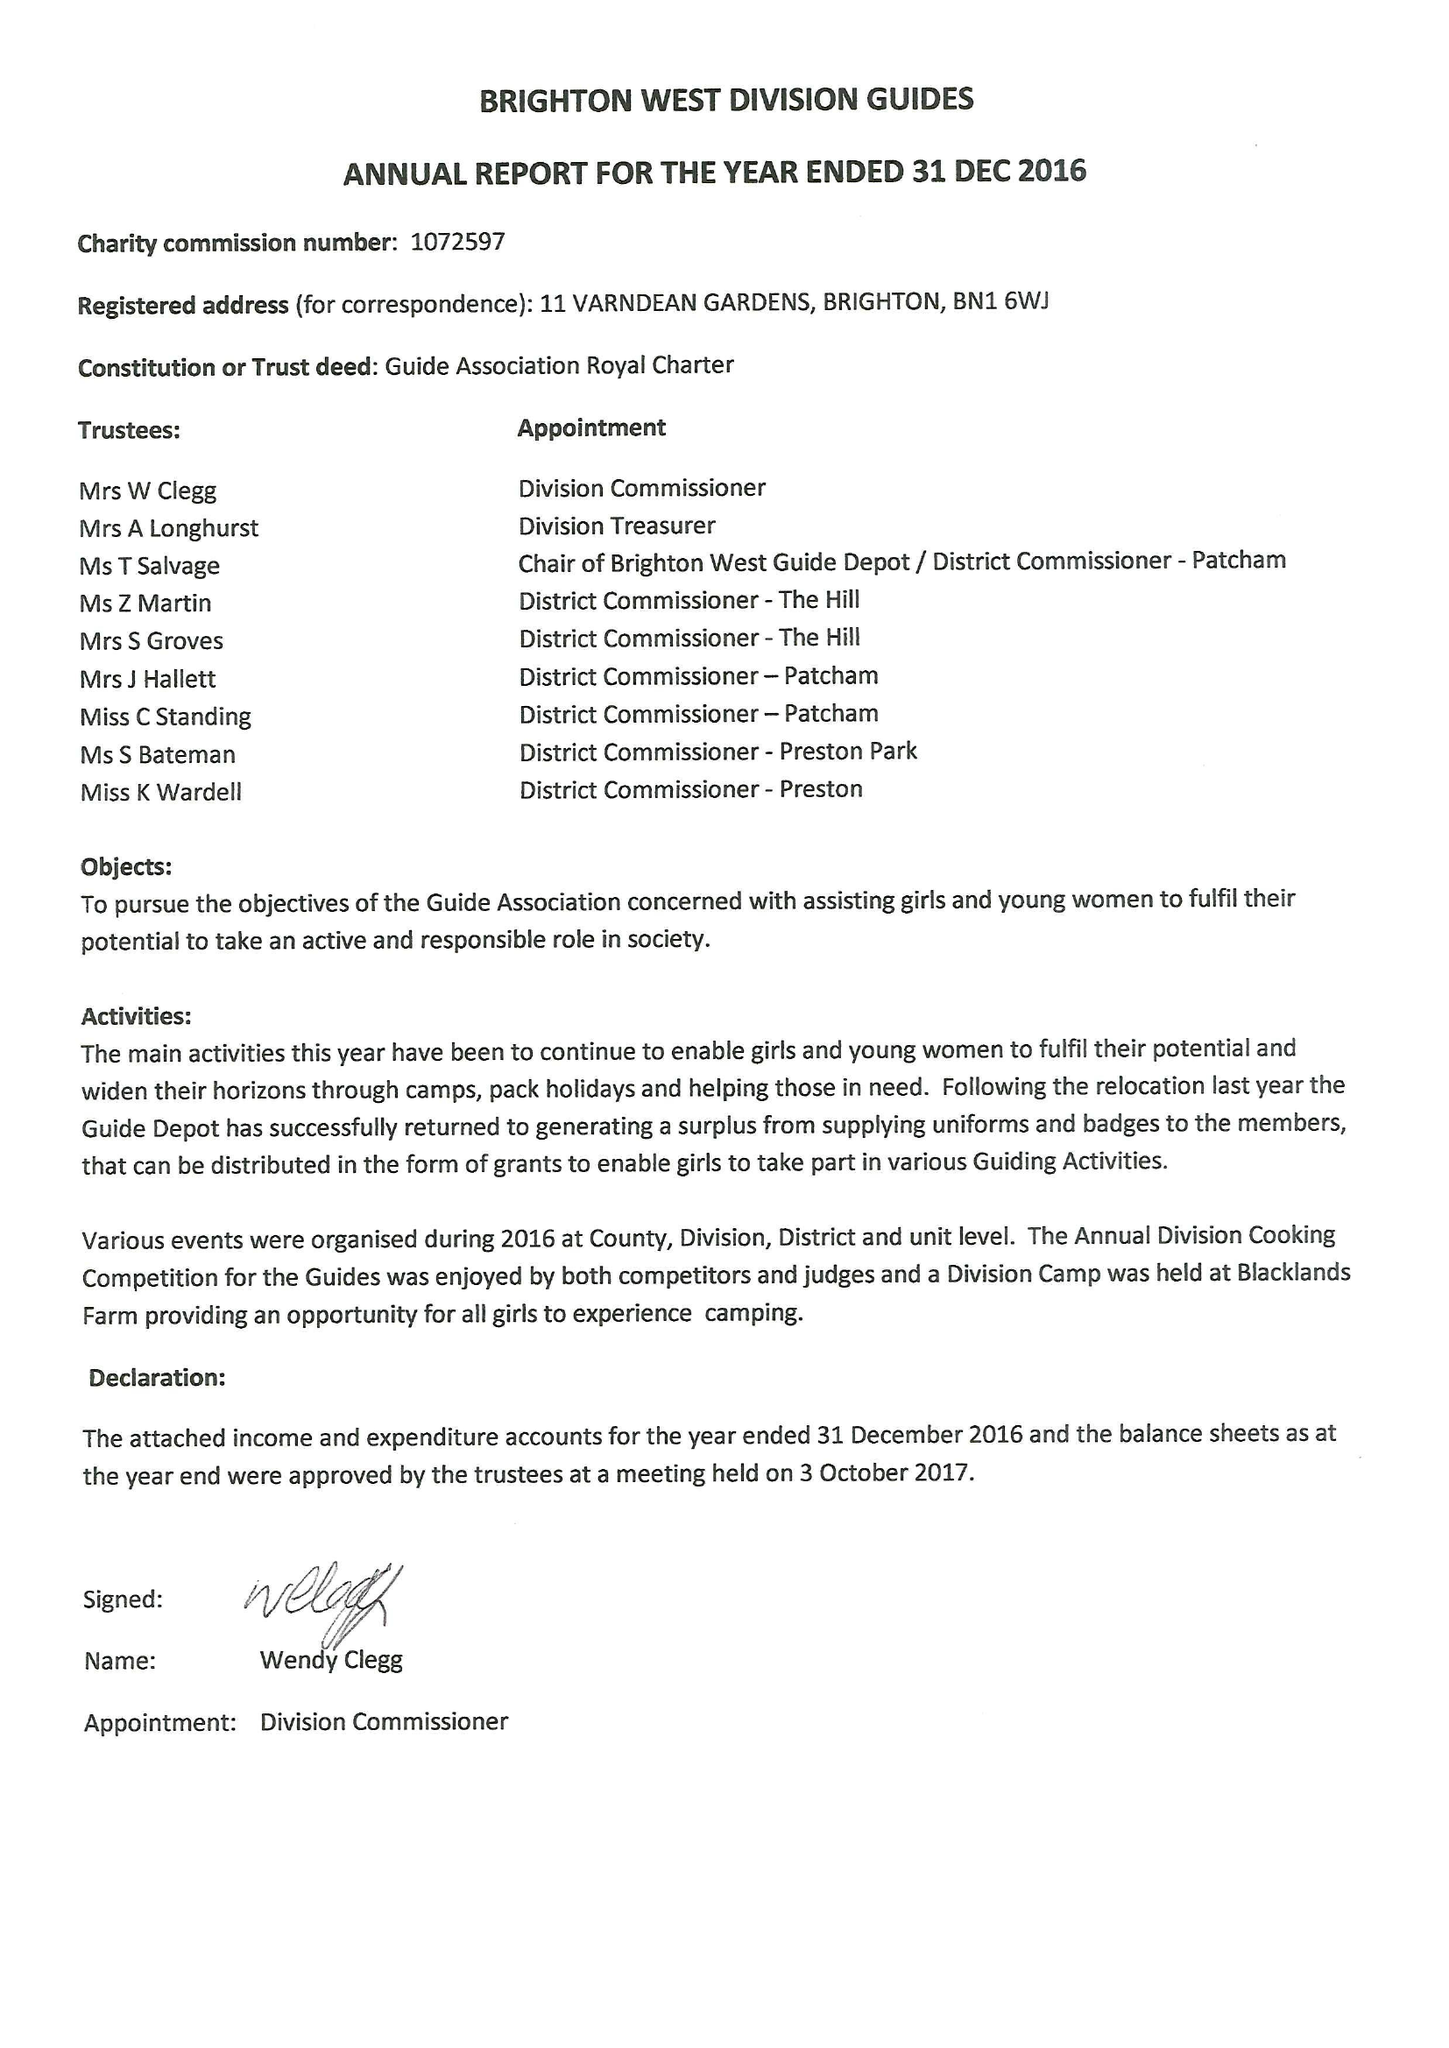What is the value for the address__postcode?
Answer the question using a single word or phrase. BN1 6WJ 